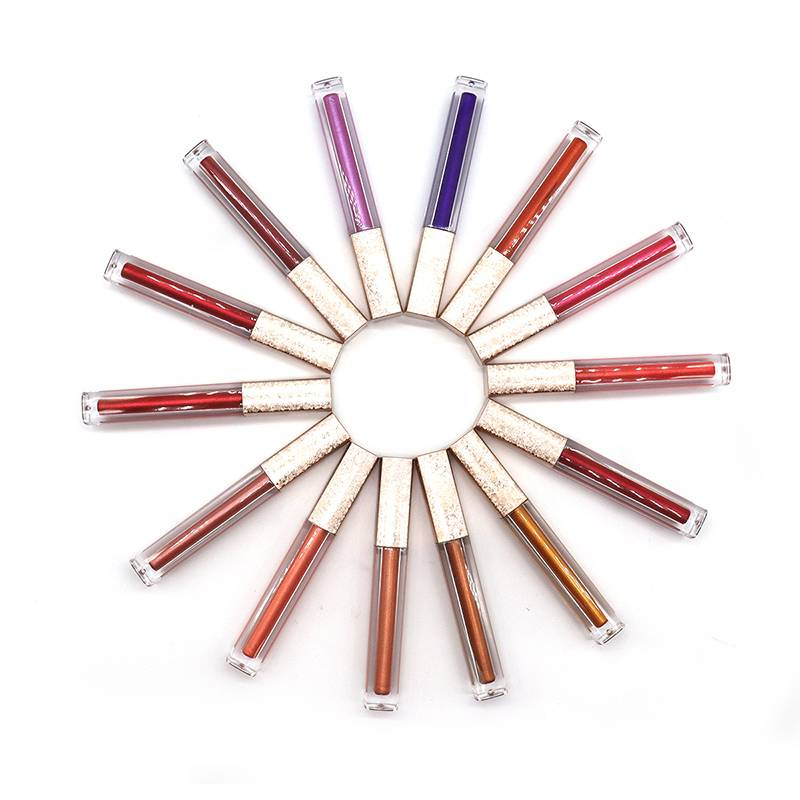If someone wanted to choose a lip gloss for a subtle, natural look, which tube would they be likely to pick? For a natural, understated appearance, the tube second from the left at the bottom, with its warm nude shade, seems ideal. Its earthy tone is close to many natural lip colors and would likely enhance the lips' innate color with just a hint of glossiness. How would that shade complement different skin tones? Warm nude shades are quite versatile and can complement a range of skin tones. On fairer skins, it might add a soft flush of color, while on medium and darker skin tones, it can accentuate the natural lip color, providing a beautiful contrast without overwhelming the overall makeup look. 